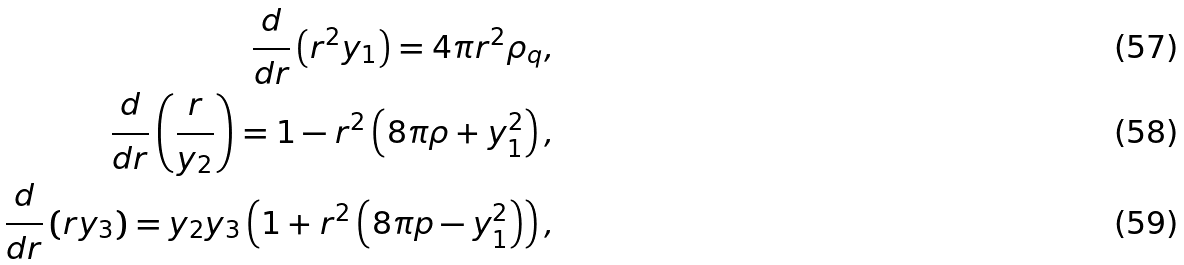Convert formula to latex. <formula><loc_0><loc_0><loc_500><loc_500>\frac { d } { d r } \left ( r ^ { 2 } y _ { 1 } \right ) = 4 \pi r ^ { 2 } \rho _ { q } , \\ \frac { d } { d r } \left ( \frac { r } { y _ { 2 } } \right ) = 1 - r ^ { 2 } \left ( 8 \pi \rho + y _ { 1 } ^ { 2 } \right ) , \\ \frac { d } { d r } \left ( r y _ { 3 } \right ) = y _ { 2 } y _ { 3 } \left ( 1 + r ^ { 2 } \left ( 8 \pi p - y _ { 1 } ^ { 2 } \right ) \right ) ,</formula> 